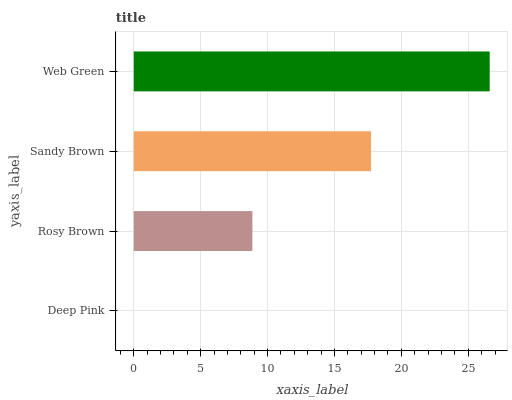Is Deep Pink the minimum?
Answer yes or no. Yes. Is Web Green the maximum?
Answer yes or no. Yes. Is Rosy Brown the minimum?
Answer yes or no. No. Is Rosy Brown the maximum?
Answer yes or no. No. Is Rosy Brown greater than Deep Pink?
Answer yes or no. Yes. Is Deep Pink less than Rosy Brown?
Answer yes or no. Yes. Is Deep Pink greater than Rosy Brown?
Answer yes or no. No. Is Rosy Brown less than Deep Pink?
Answer yes or no. No. Is Sandy Brown the high median?
Answer yes or no. Yes. Is Rosy Brown the low median?
Answer yes or no. Yes. Is Deep Pink the high median?
Answer yes or no. No. Is Deep Pink the low median?
Answer yes or no. No. 